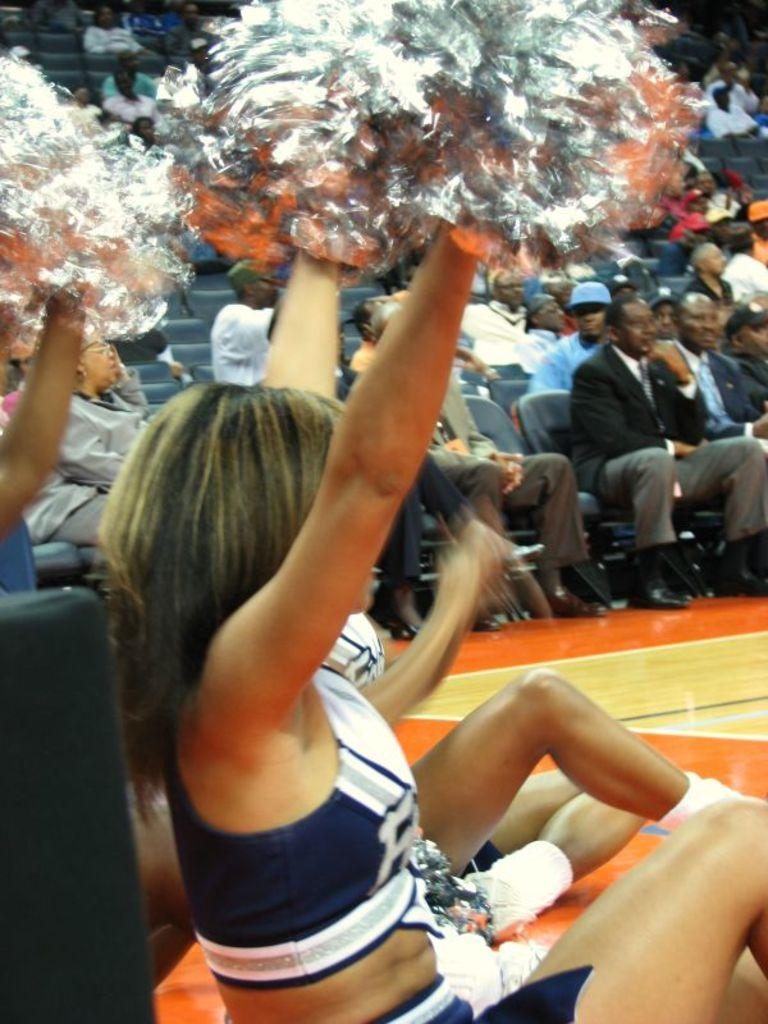Who is the main subject in the image? There is a lady in the image. What is the lady holding in the image? The lady is holding something. Can you describe the other people in the image? The other people in the image are sitting on chairs. What type of screw is the lady using to fix the skirt in the image? There is no screw or skirt present in the image. What is the lady's occupation as a porter in the image? There is no indication of the lady's occupation in the image. 